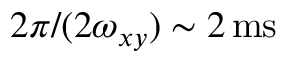<formula> <loc_0><loc_0><loc_500><loc_500>2 \pi / ( 2 \omega _ { x y } ) \sim 2 \, m s</formula> 